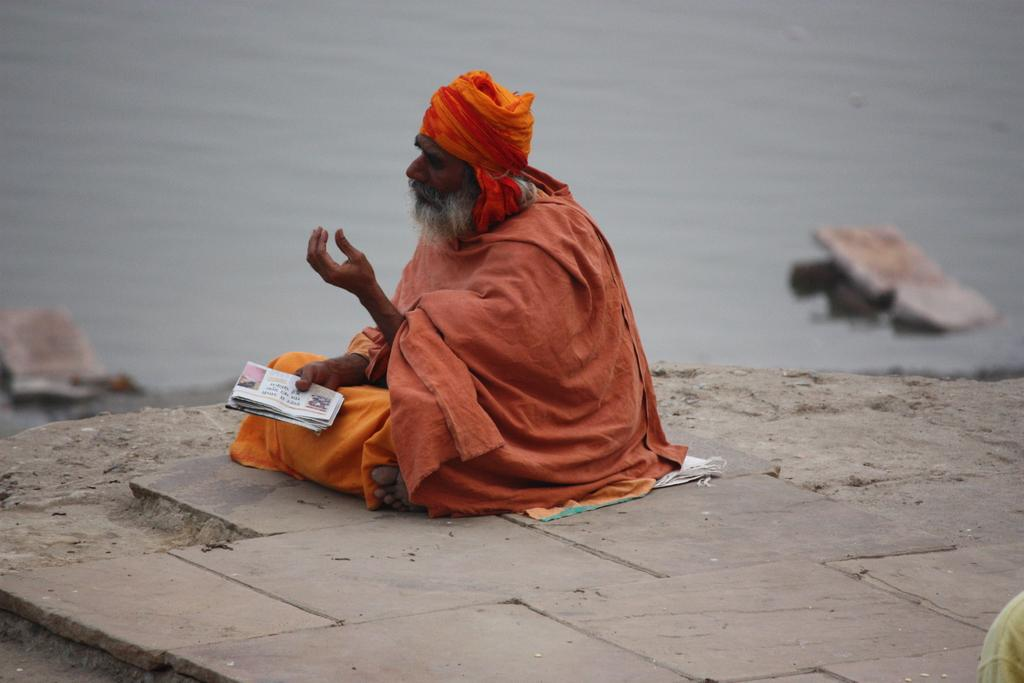What is the person in the image doing? The person is sitting on the ground in the image. What is the person holding in his hand? The person is holding a paper in his hand. What can be seen in the background of the image? There is a river in the background of the image. How does the person kick the nut in the image? There is no nut present in the image, so the person cannot kick a nut. 